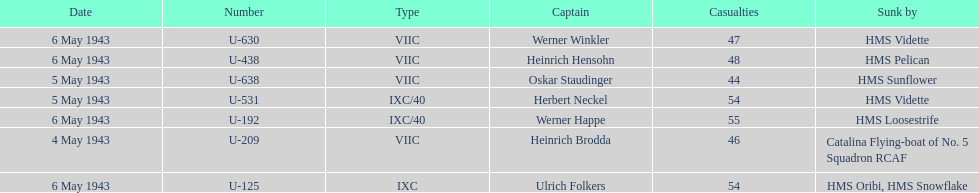How many captains are listed? 7. 